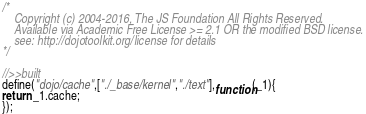<code> <loc_0><loc_0><loc_500><loc_500><_JavaScript_>/*
	Copyright (c) 2004-2016, The JS Foundation All Rights Reserved.
	Available via Academic Free License >= 2.1 OR the modified BSD license.
	see: http://dojotoolkit.org/license for details
*/

//>>built
define("dojo/cache",["./_base/kernel","./text"],function(_1){
return _1.cache;
});
</code> 